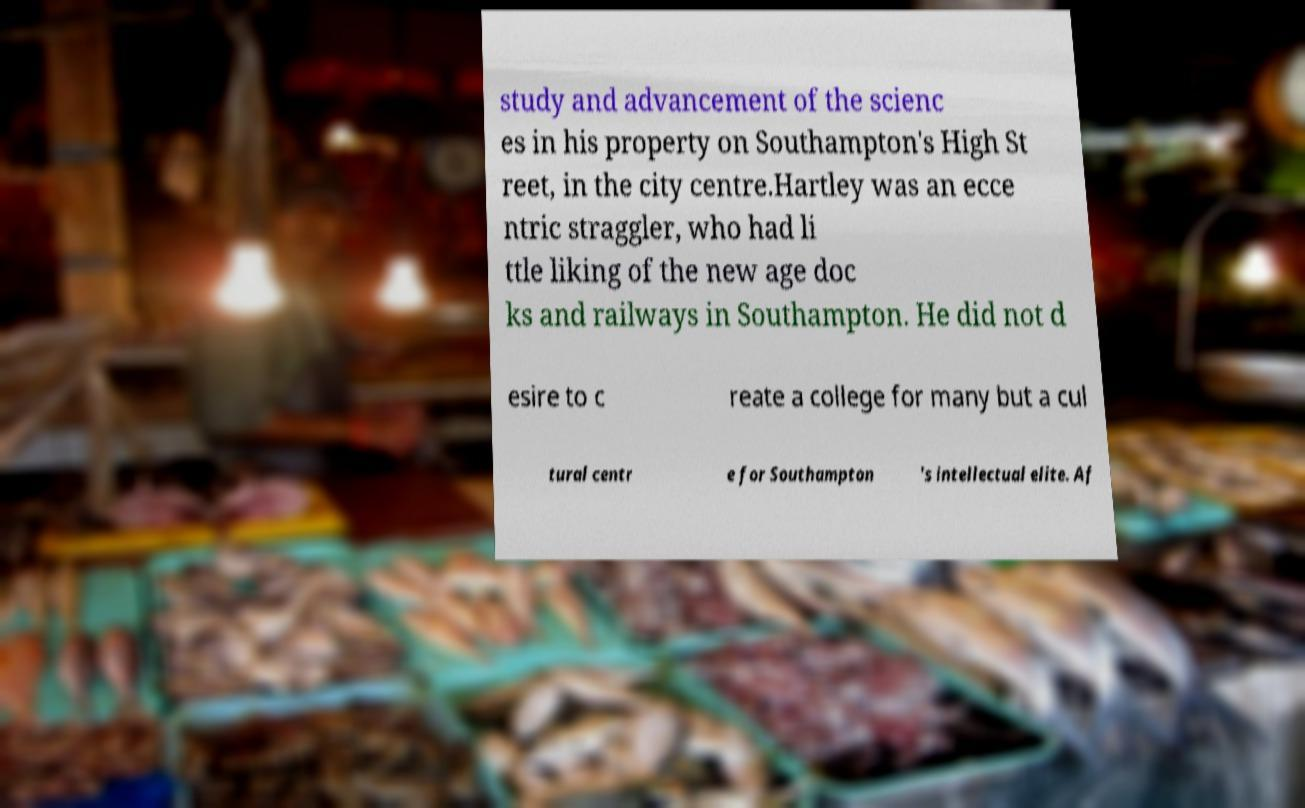I need the written content from this picture converted into text. Can you do that? study and advancement of the scienc es in his property on Southampton's High St reet, in the city centre.Hartley was an ecce ntric straggler, who had li ttle liking of the new age doc ks and railways in Southampton. He did not d esire to c reate a college for many but a cul tural centr e for Southampton 's intellectual elite. Af 